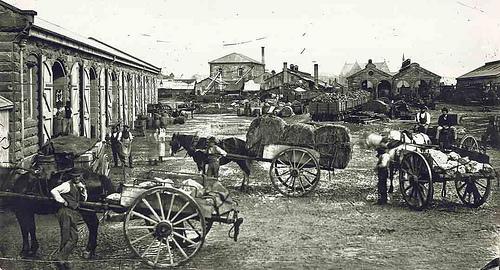Is this a normal thing to see in recent history?
Answer briefly. No. What animals are shown?
Be succinct. Horses. Is this photo taken in a city center?
Be succinct. Yes. 